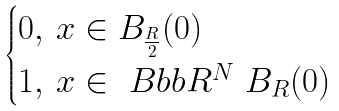<formula> <loc_0><loc_0><loc_500><loc_500>\begin{cases} 0 , \, x \in B _ { \frac { R } { 2 } } ( 0 ) \\ 1 , \, x \in \ B b b R ^ { N } \ B _ { R } ( 0 ) \end{cases}</formula> 